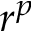<formula> <loc_0><loc_0><loc_500><loc_500>r ^ { p }</formula> 